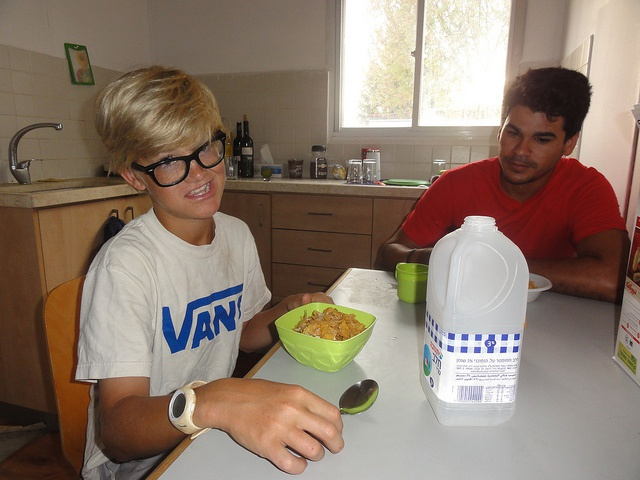Describe the objects in this image and their specific colors. I can see people in gray, darkgray, and maroon tones, dining table in gray, darkgray, and lightgray tones, people in gray, maroon, black, and brown tones, bottle in gray, lightgray, and darkgray tones, and chair in gray and maroon tones in this image. 